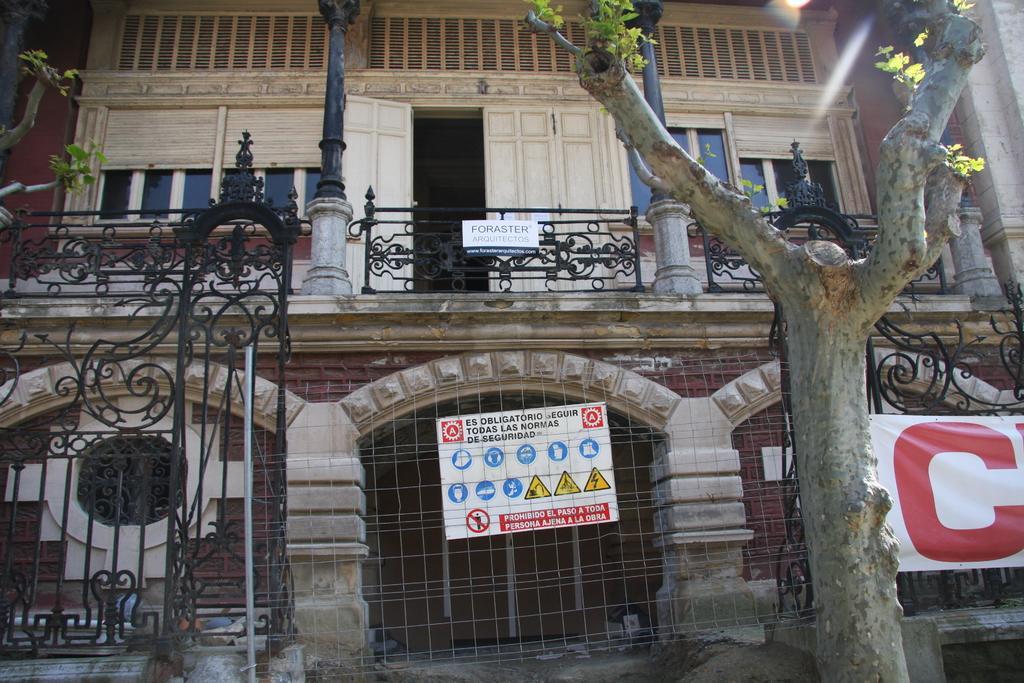Describe this image in one or two sentences. In this image we can see a building. On the building we can see the windows and railings. On the railing we can see a board with text. In front of the building we can see a wall with fencing and a tree. On the fencing we can see a broad and banner with text. 